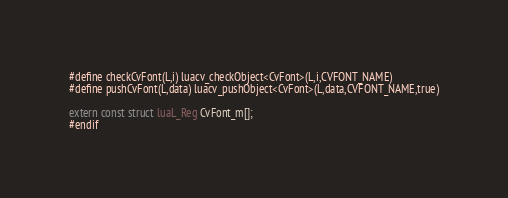<code> <loc_0><loc_0><loc_500><loc_500><_C_>
#define checkCvFont(L,i) luacv_checkObject<CvFont>(L,i,CVFONT_NAME)
#define pushCvFont(L,data) luacv_pushObject<CvFont>(L,data,CVFONT_NAME,true)

extern const struct luaL_Reg CvFont_m[];
#endif
</code> 